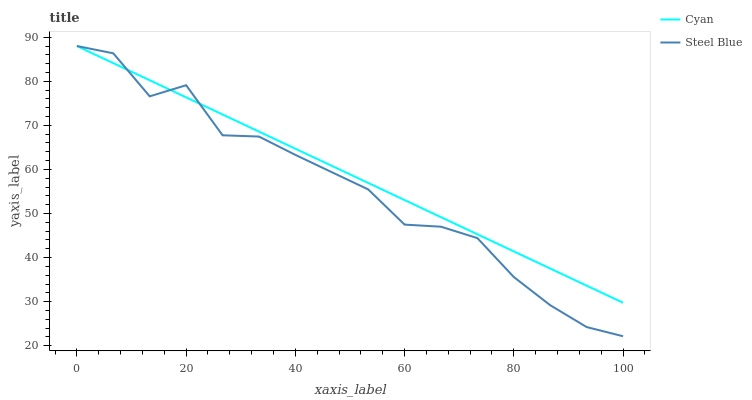Does Steel Blue have the minimum area under the curve?
Answer yes or no. Yes. Does Cyan have the maximum area under the curve?
Answer yes or no. Yes. Does Steel Blue have the maximum area under the curve?
Answer yes or no. No. Is Cyan the smoothest?
Answer yes or no. Yes. Is Steel Blue the roughest?
Answer yes or no. Yes. Is Steel Blue the smoothest?
Answer yes or no. No. Does Steel Blue have the lowest value?
Answer yes or no. Yes. Does Steel Blue have the highest value?
Answer yes or no. Yes. Does Steel Blue intersect Cyan?
Answer yes or no. Yes. Is Steel Blue less than Cyan?
Answer yes or no. No. Is Steel Blue greater than Cyan?
Answer yes or no. No. 